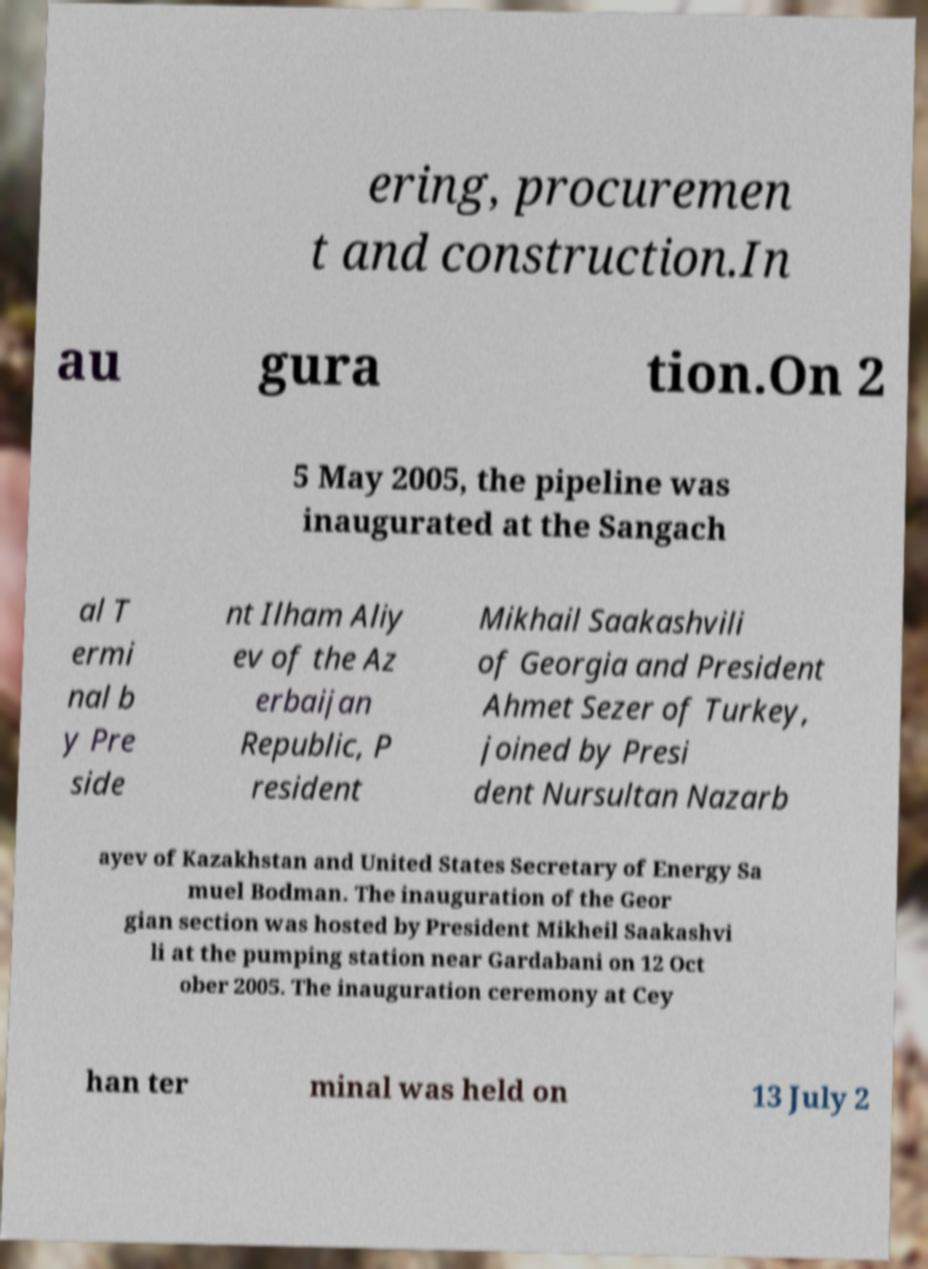Could you assist in decoding the text presented in this image and type it out clearly? ering, procuremen t and construction.In au gura tion.On 2 5 May 2005, the pipeline was inaugurated at the Sangach al T ermi nal b y Pre side nt Ilham Aliy ev of the Az erbaijan Republic, P resident Mikhail Saakashvili of Georgia and President Ahmet Sezer of Turkey, joined by Presi dent Nursultan Nazarb ayev of Kazakhstan and United States Secretary of Energy Sa muel Bodman. The inauguration of the Geor gian section was hosted by President Mikheil Saakashvi li at the pumping station near Gardabani on 12 Oct ober 2005. The inauguration ceremony at Cey han ter minal was held on 13 July 2 